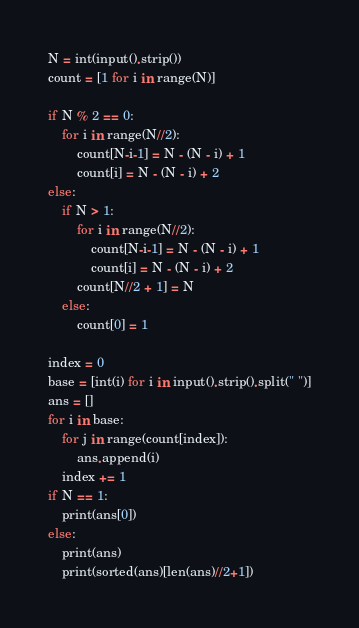<code> <loc_0><loc_0><loc_500><loc_500><_Python_>N = int(input().strip())
count = [1 for i in range(N)]

if N % 2 == 0:
    for i in range(N//2):
        count[N-i-1] = N - (N - i) + 1
        count[i] = N - (N - i) + 2
else:
    if N > 1:
        for i in range(N//2):
            count[N-i-1] = N - (N - i) + 1
            count[i] = N - (N - i) + 2
        count[N//2 + 1] = N
    else:
        count[0] = 1

index = 0
base = [int(i) for i in input().strip().split(" ")]
ans = []
for i in base:
    for j in range(count[index]):
        ans.append(i)
    index += 1
if N == 1:
    print(ans[0])
else:
    print(ans)
    print(sorted(ans)[len(ans)//2+1])
</code> 